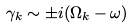Convert formula to latex. <formula><loc_0><loc_0><loc_500><loc_500>\gamma _ { k } \sim \pm i ( \Omega _ { k } - \omega )</formula> 